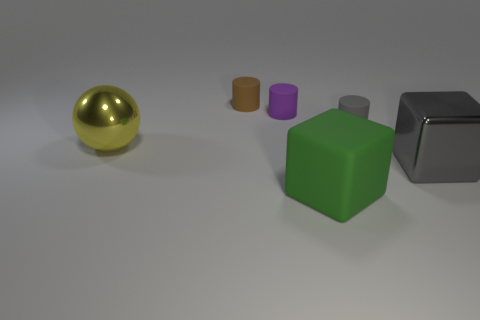There is a big rubber thing; what number of yellow metal balls are left of it?
Keep it short and to the point. 1. The thing that is on the left side of the small purple thing and in front of the small brown rubber thing is made of what material?
Your response must be concise. Metal. What number of balls are the same size as the purple matte cylinder?
Your answer should be compact. 0. What is the color of the thing in front of the big block that is right of the matte cube?
Offer a terse response. Green. Are there any purple matte cylinders?
Make the answer very short. Yes. Does the tiny purple matte thing have the same shape as the big rubber object?
Make the answer very short. No. There is a rubber cylinder that is the same color as the metal cube; what size is it?
Your answer should be compact. Small. How many brown matte cylinders are in front of the gray thing behind the big metallic cube?
Make the answer very short. 0. What number of objects are both on the right side of the big yellow sphere and to the left of the matte block?
Make the answer very short. 2. What number of things are gray things or objects to the right of the tiny gray rubber cylinder?
Your response must be concise. 2. 